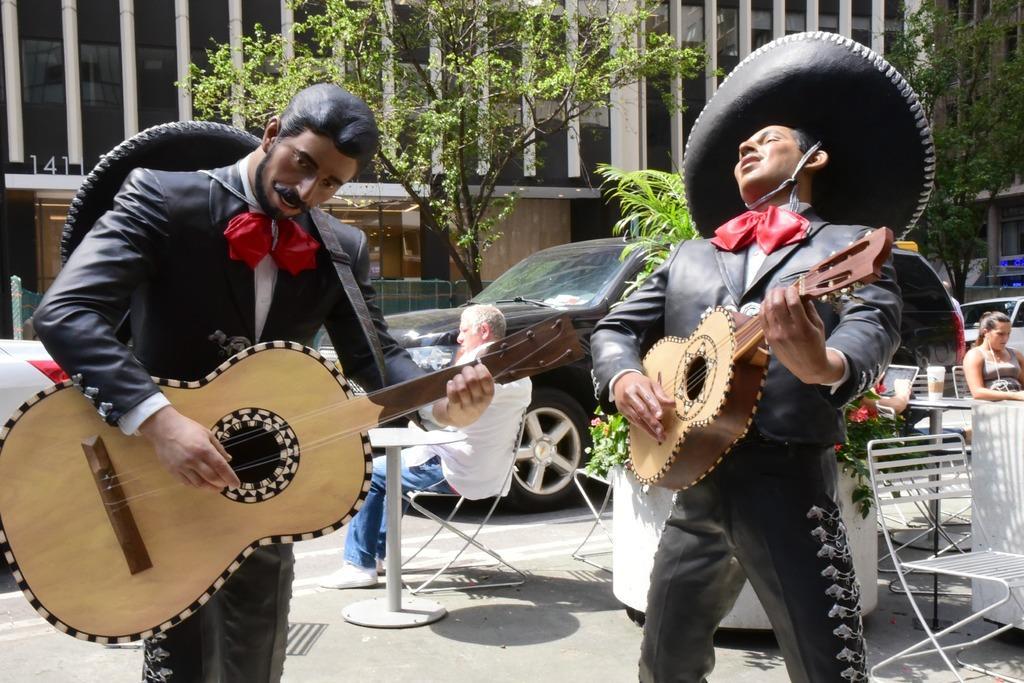Describe this image in one or two sentences. In the middle of the image there is a man sitting on a chair. Behind there is a car. In the middle of the image there is a tree, Behind there is a building. Top right side of the image there is a tree. Bottom right side of the image a woman sitting on a chair and listening. Left side of the image there is a man playing guitar. Right side of the image there is a man playing guitar. 